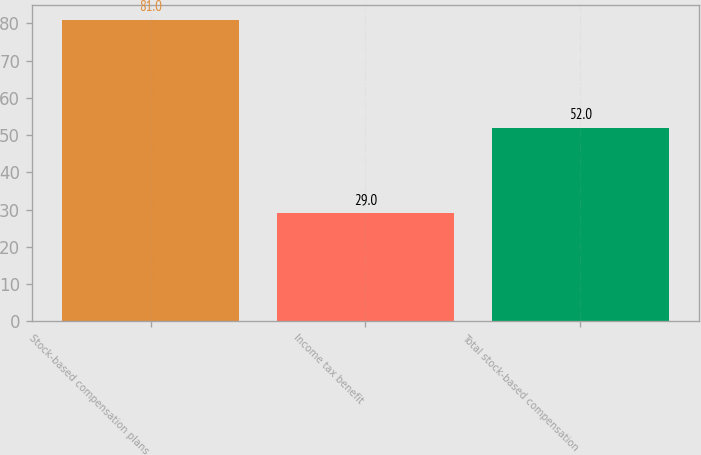<chart> <loc_0><loc_0><loc_500><loc_500><bar_chart><fcel>Stock-based compensation plans<fcel>Income tax benefit<fcel>Total stock-based compensation<nl><fcel>81<fcel>29<fcel>52<nl></chart> 